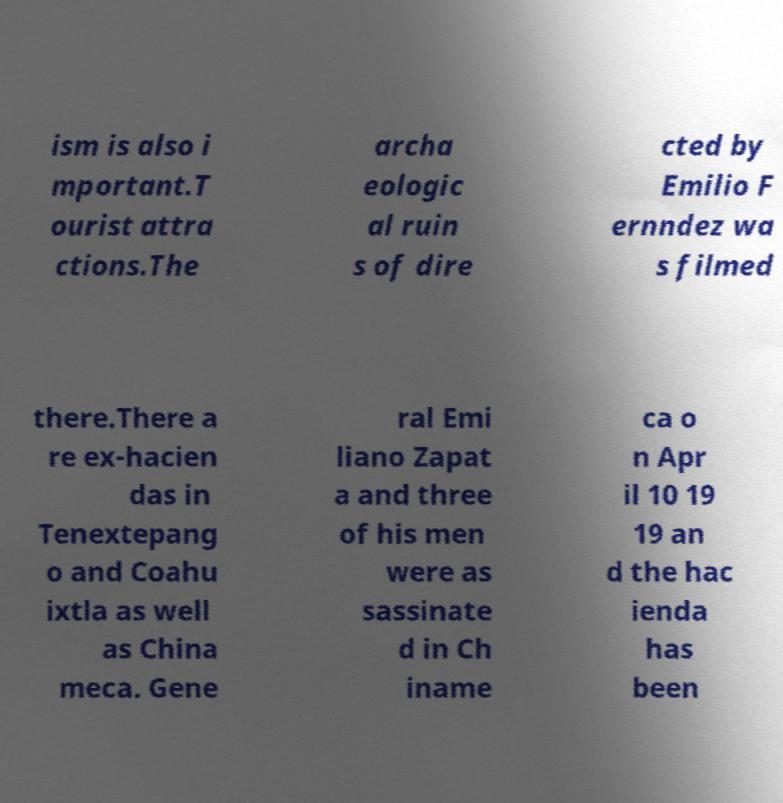What messages or text are displayed in this image? I need them in a readable, typed format. ism is also i mportant.T ourist attra ctions.The archa eologic al ruin s of dire cted by Emilio F ernndez wa s filmed there.There a re ex-hacien das in Tenextepang o and Coahu ixtla as well as China meca. Gene ral Emi liano Zapat a and three of his men were as sassinate d in Ch iname ca o n Apr il 10 19 19 an d the hac ienda has been 